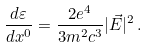<formula> <loc_0><loc_0><loc_500><loc_500>\frac { d \varepsilon } { d x ^ { 0 } } = \frac { 2 e ^ { 4 } } { 3 m ^ { 2 } c ^ { 3 } } | \vec { E } | ^ { 2 } \, { . }</formula> 